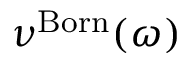Convert formula to latex. <formula><loc_0><loc_0><loc_500><loc_500>\nu ^ { B o r n } ( \omega )</formula> 